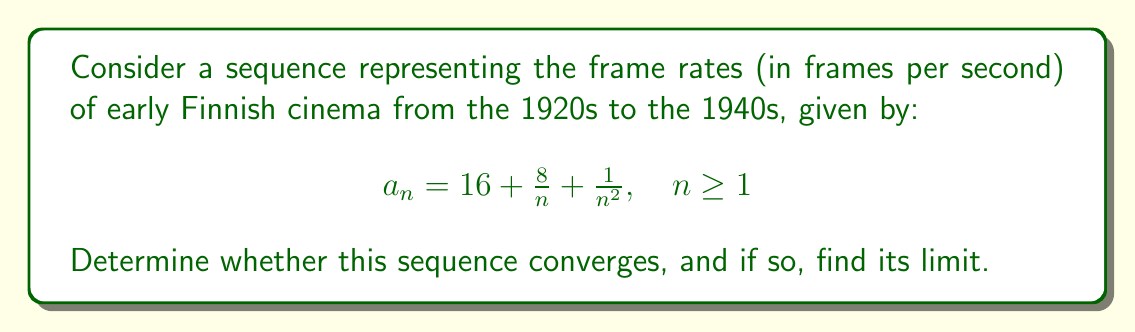Solve this math problem. To determine the convergence of this sequence, we'll analyze its behavior as $n$ approaches infinity:

1) First, let's examine each term of the sequence:
   
   - The constant term: 16
   - The term $\frac{8}{n}$
   - The term $\frac{1}{n^2}$

2) As $n$ approaches infinity:
   
   - 16 remains constant
   - $\lim_{n \to \infty} \frac{8}{n} = 0$
   - $\lim_{n \to \infty} \frac{1}{n^2} = 0$

3) Using the limit laws, we can conclude:

   $$\lim_{n \to \infty} a_n = \lim_{n \to \infty} (16 + \frac{8}{n} + \frac{1}{n^2}) = 16 + 0 + 0 = 16$$

4) Since the limit exists and is finite, the sequence converges.

5) To verify, we can use the definition of convergence:

   For any $\epsilon > 0$, we need to find an $N$ such that for all $n > N$,
   $|a_n - 16| < \epsilon$

   $|a_n - 16| = |\frac{8}{n} + \frac{1}{n^2}| \leq \frac{8}{n} + \frac{1}{n^2} < \frac{9}{n}$ (for $n \geq 1$)

   So, we need $\frac{9}{n} < \epsilon$, or $n > \frac{9}{\epsilon}$

   Therefore, we can choose $N = \lceil\frac{9}{\epsilon}\rceil$, the ceiling of $\frac{9}{\epsilon}$.

Thus, we have proven that the sequence converges to 16.

This result suggests that as Finnish cinema technology progressed from the 1920s to the 1940s, the frame rate stabilized around 16 frames per second, which is consistent with historical film technology of that era.
Answer: The sequence converges, and its limit is 16. 